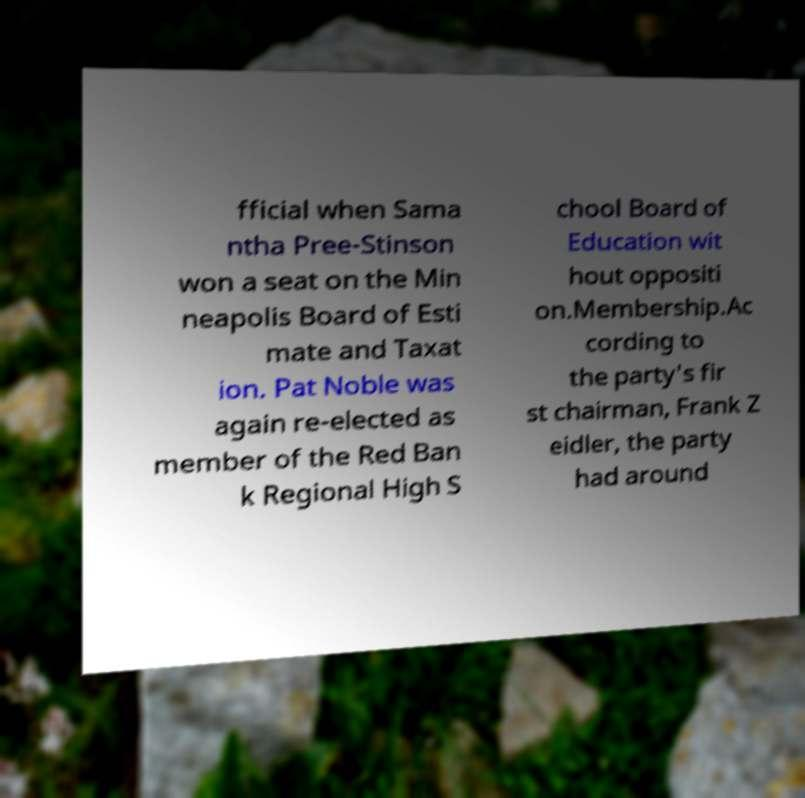Can you accurately transcribe the text from the provided image for me? fficial when Sama ntha Pree-Stinson won a seat on the Min neapolis Board of Esti mate and Taxat ion. Pat Noble was again re-elected as member of the Red Ban k Regional High S chool Board of Education wit hout oppositi on.Membership.Ac cording to the party's fir st chairman, Frank Z eidler, the party had around 